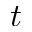<formula> <loc_0><loc_0><loc_500><loc_500>t</formula> 